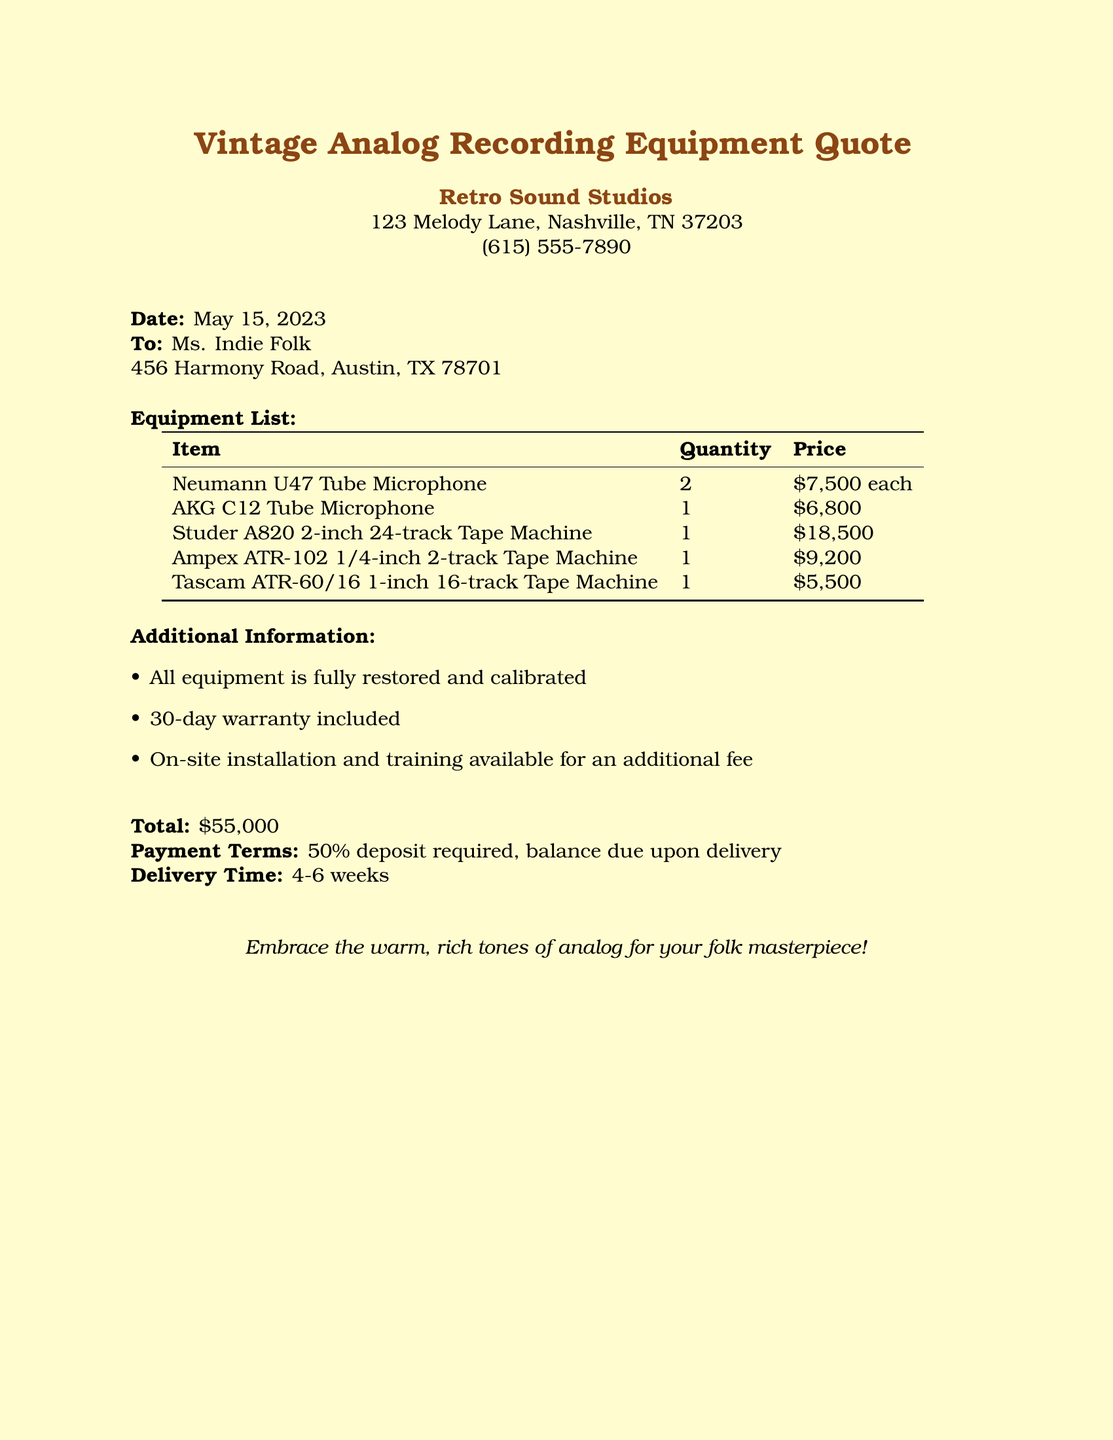What is the total amount quoted for the equipment? The total amount is stated clearly in the document, which sums up to $55,000.
Answer: $55,000 What is the price of the Neumann U47 Tube Microphone? The price for each Neumann U47 Tube Microphone is specified in the equipment list as $7,500 each.
Answer: $7,500 How many AKG C12 Tube Microphones are included in the quote? The document lists the quantity of AKG C12 Tube Microphone, showing that there is 1 in the equipment list.
Answer: 1 What is the delivery time mentioned in the quote? The document states a delivery time of 4-6 weeks for the equipment.
Answer: 4-6 weeks Is on-site installation available? The document indicates that on-site installation is available for an additional fee, confirming its availability.
Answer: Yes What warranty period is included with the equipment? The warranty period included is specified as a 30-day warranty in the additional information section.
Answer: 30-day How many Studer A820 2-inch 24-track Tape Machines are in the quote? The equipment list shows that there is 1 Studer A820 2-inch 24-track Tape Machine in the quote.
Answer: 1 Who is the recipient of the quote? The document addresses Ms. Indie Folk as the recipient of the quote.
Answer: Ms. Indie Folk What is required as payment terms? The payment terms specify that a 50% deposit is required, along with the balance due upon delivery.
Answer: 50% deposit required 